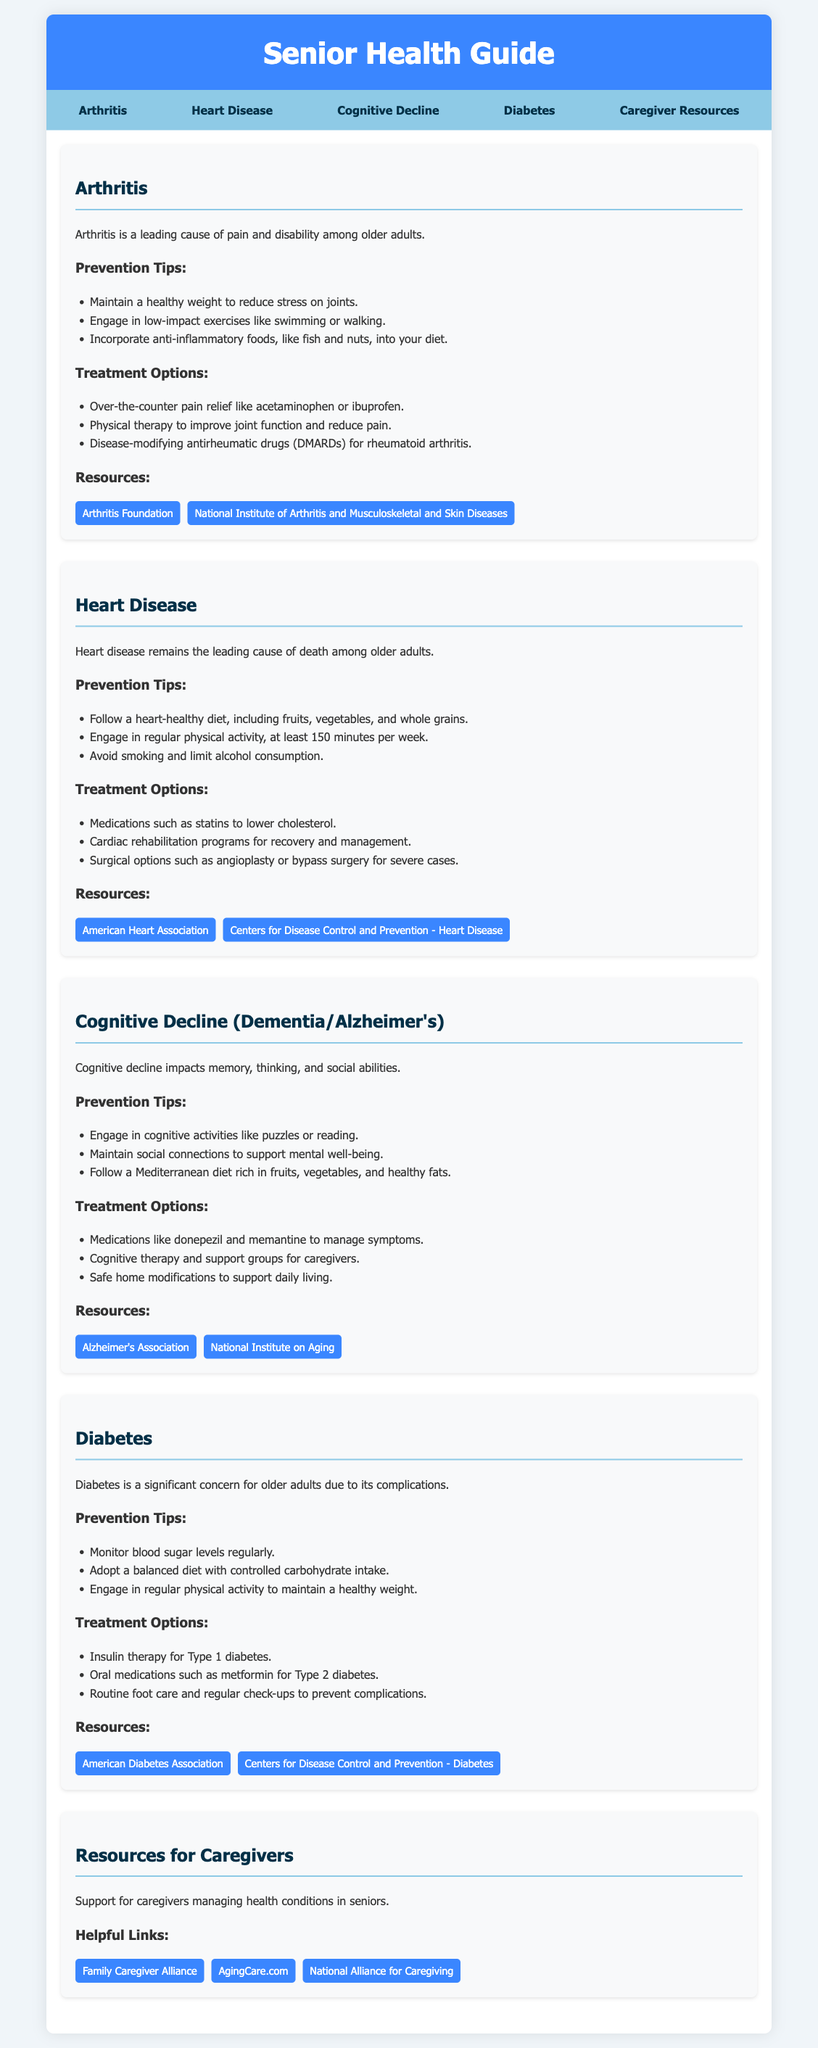What is a leading cause of pain and disability among older adults? The document states that arthritis is a leading cause of pain and disability among older adults.
Answer: Arthritis What is the recommended physical activity duration per week to prevent heart disease? The document suggests engaging in regular physical activity of at least 150 minutes per week.
Answer: 150 minutes Which medication is commonly used for Type 2 diabetes? The document lists metformin as an oral medication for Type 2 diabetes.
Answer: Metformin What type of diet is recommended to support cognitive health? The document mentions a Mediterranean diet, which is rich in fruits, vegetables, and healthy fats.
Answer: Mediterranean diet How many resources are provided for caregivers? The document lists three helpful links for caregivers under the resources section for caregivers.
Answer: Three What can be used as pain relief for arthritis? The document indicates that over-the-counter pain relief options include acetaminophen or ibuprofen for arthritis.
Answer: Acetaminophen or ibuprofen What organization is linked for more information on Alzheimer's? The document provides a link to the Alzheimer's Association for more information on Alzheimer's.
Answer: Alzheimer's Association What type of therapy is mentioned for cognitive therapy and support? The document refers to cognitive therapy as a treatment option for managing cognitive decline.
Answer: Cognitive therapy 